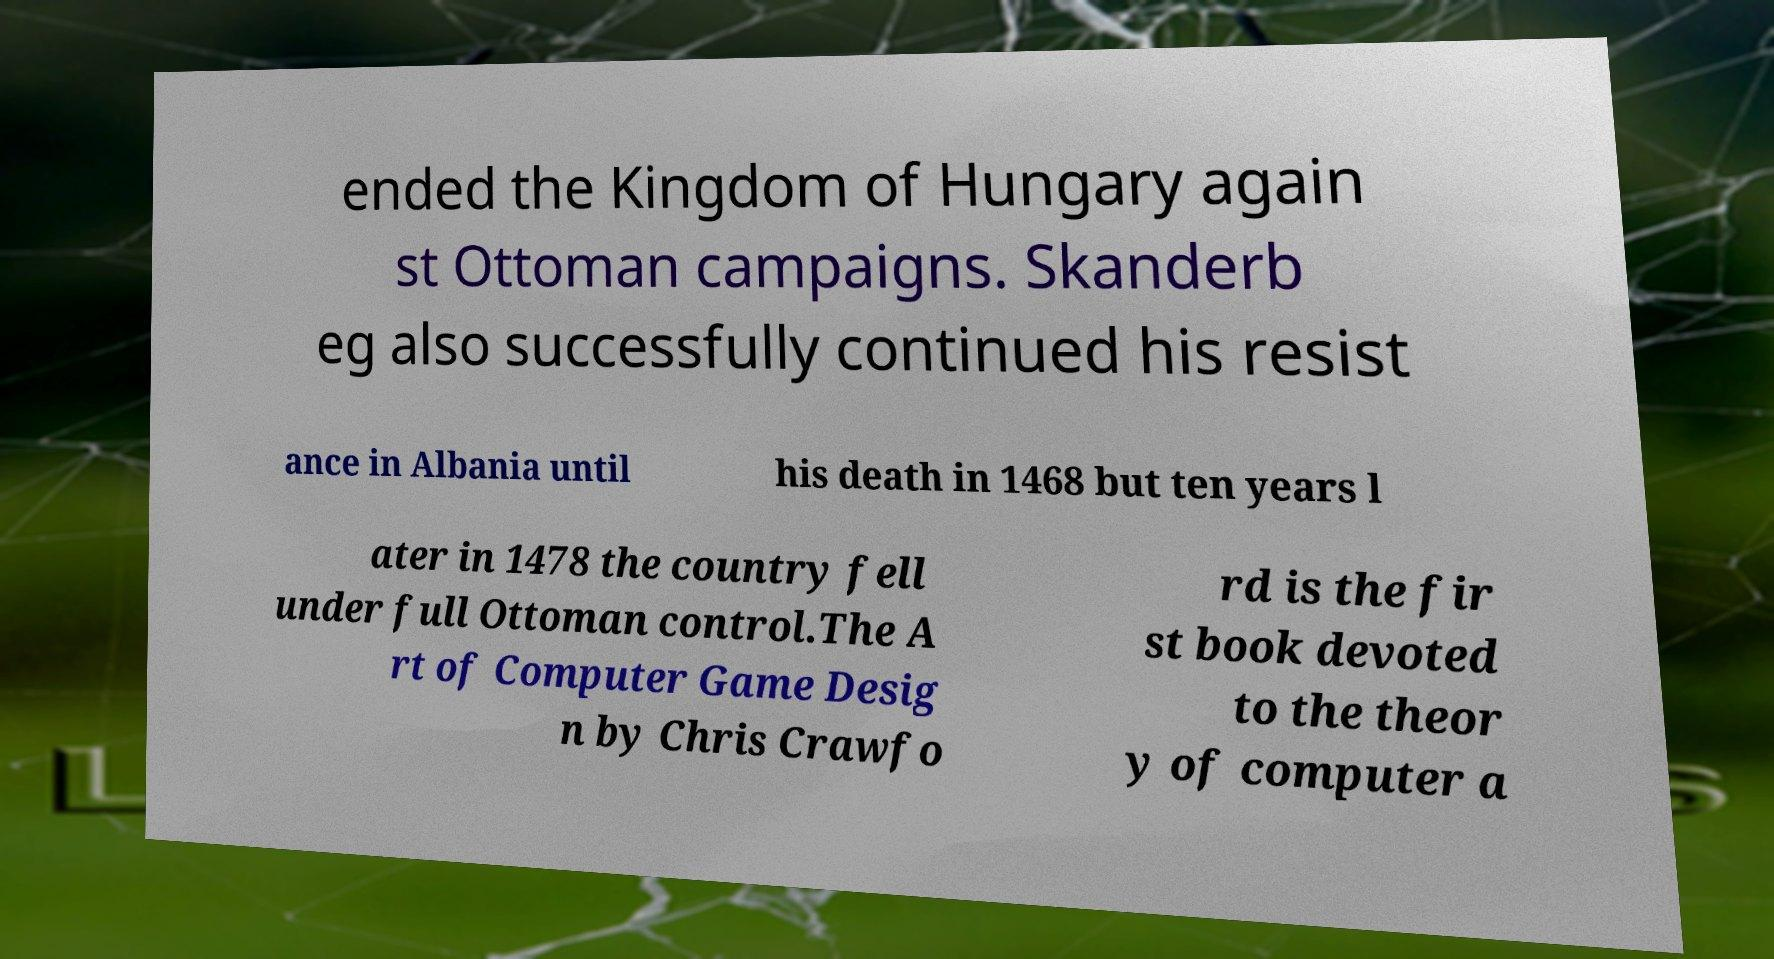Could you assist in decoding the text presented in this image and type it out clearly? ended the Kingdom of Hungary again st Ottoman campaigns. Skanderb eg also successfully continued his resist ance in Albania until his death in 1468 but ten years l ater in 1478 the country fell under full Ottoman control.The A rt of Computer Game Desig n by Chris Crawfo rd is the fir st book devoted to the theor y of computer a 